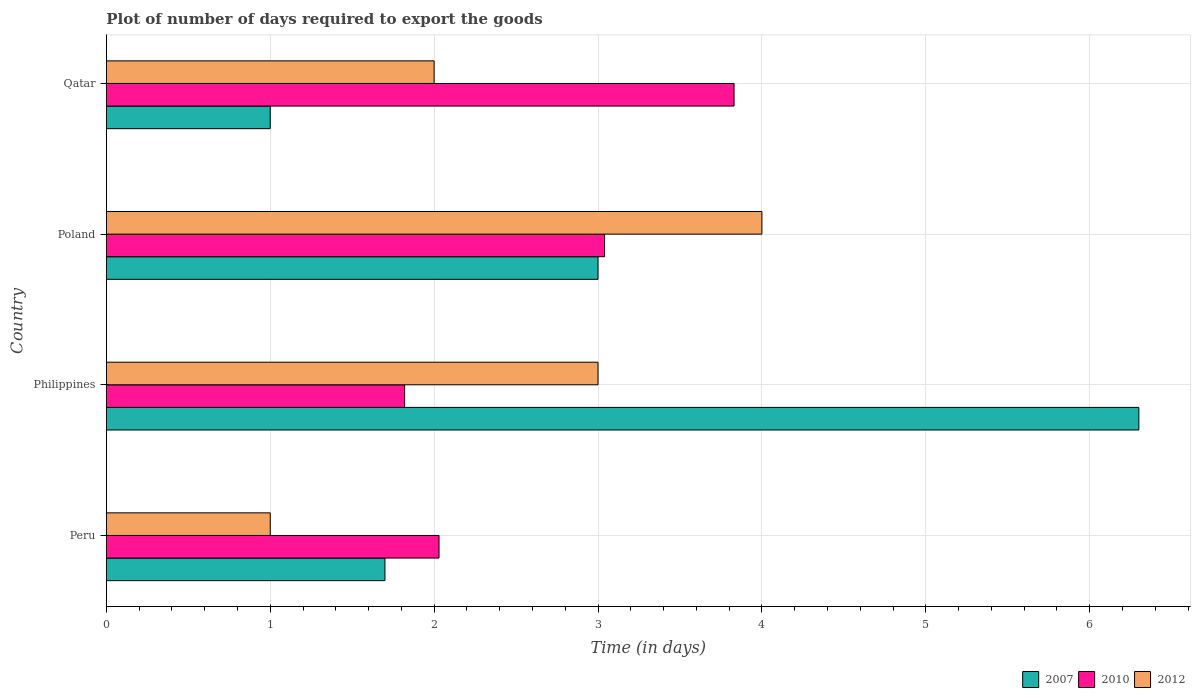How many bars are there on the 4th tick from the top?
Ensure brevity in your answer.  3. What is the label of the 1st group of bars from the top?
Offer a terse response. Qatar. What is the time required to export goods in 2010 in Philippines?
Ensure brevity in your answer.  1.82. Across all countries, what is the maximum time required to export goods in 2010?
Make the answer very short. 3.83. Across all countries, what is the minimum time required to export goods in 2010?
Offer a very short reply. 1.82. In which country was the time required to export goods in 2012 maximum?
Make the answer very short. Poland. What is the total time required to export goods in 2010 in the graph?
Ensure brevity in your answer.  10.72. What is the difference between the time required to export goods in 2010 in Poland and the time required to export goods in 2007 in Philippines?
Your response must be concise. -3.26. In how many countries, is the time required to export goods in 2007 greater than 1.6 days?
Keep it short and to the point. 3. Is the time required to export goods in 2012 in Philippines less than that in Qatar?
Ensure brevity in your answer.  No. Is the difference between the time required to export goods in 2012 in Poland and Qatar greater than the difference between the time required to export goods in 2007 in Poland and Qatar?
Ensure brevity in your answer.  No. In how many countries, is the time required to export goods in 2012 greater than the average time required to export goods in 2012 taken over all countries?
Ensure brevity in your answer.  2. What does the 3rd bar from the bottom in Poland represents?
Keep it short and to the point. 2012. How many bars are there?
Offer a terse response. 12. Does the graph contain grids?
Ensure brevity in your answer.  Yes. Where does the legend appear in the graph?
Your response must be concise. Bottom right. How many legend labels are there?
Provide a short and direct response. 3. What is the title of the graph?
Offer a terse response. Plot of number of days required to export the goods. What is the label or title of the X-axis?
Your answer should be compact. Time (in days). What is the Time (in days) in 2010 in Peru?
Make the answer very short. 2.03. What is the Time (in days) of 2012 in Peru?
Keep it short and to the point. 1. What is the Time (in days) of 2010 in Philippines?
Offer a very short reply. 1.82. What is the Time (in days) of 2012 in Philippines?
Your answer should be compact. 3. What is the Time (in days) in 2010 in Poland?
Give a very brief answer. 3.04. What is the Time (in days) in 2012 in Poland?
Offer a terse response. 4. What is the Time (in days) of 2010 in Qatar?
Offer a terse response. 3.83. What is the Time (in days) in 2012 in Qatar?
Keep it short and to the point. 2. Across all countries, what is the maximum Time (in days) in 2010?
Give a very brief answer. 3.83. Across all countries, what is the minimum Time (in days) of 2007?
Offer a very short reply. 1. Across all countries, what is the minimum Time (in days) in 2010?
Ensure brevity in your answer.  1.82. Across all countries, what is the minimum Time (in days) of 2012?
Your response must be concise. 1. What is the total Time (in days) in 2007 in the graph?
Give a very brief answer. 12. What is the total Time (in days) of 2010 in the graph?
Give a very brief answer. 10.72. What is the difference between the Time (in days) of 2007 in Peru and that in Philippines?
Keep it short and to the point. -4.6. What is the difference between the Time (in days) in 2010 in Peru and that in Philippines?
Provide a succinct answer. 0.21. What is the difference between the Time (in days) of 2007 in Peru and that in Poland?
Ensure brevity in your answer.  -1.3. What is the difference between the Time (in days) of 2010 in Peru and that in Poland?
Your answer should be very brief. -1.01. What is the difference between the Time (in days) in 2012 in Peru and that in Poland?
Ensure brevity in your answer.  -3. What is the difference between the Time (in days) of 2010 in Philippines and that in Poland?
Offer a very short reply. -1.22. What is the difference between the Time (in days) in 2012 in Philippines and that in Poland?
Keep it short and to the point. -1. What is the difference between the Time (in days) of 2007 in Philippines and that in Qatar?
Keep it short and to the point. 5.3. What is the difference between the Time (in days) in 2010 in Philippines and that in Qatar?
Your response must be concise. -2.01. What is the difference between the Time (in days) in 2012 in Philippines and that in Qatar?
Your answer should be very brief. 1. What is the difference between the Time (in days) in 2010 in Poland and that in Qatar?
Give a very brief answer. -0.79. What is the difference between the Time (in days) of 2007 in Peru and the Time (in days) of 2010 in Philippines?
Give a very brief answer. -0.12. What is the difference between the Time (in days) of 2007 in Peru and the Time (in days) of 2012 in Philippines?
Give a very brief answer. -1.3. What is the difference between the Time (in days) of 2010 in Peru and the Time (in days) of 2012 in Philippines?
Offer a terse response. -0.97. What is the difference between the Time (in days) in 2007 in Peru and the Time (in days) in 2010 in Poland?
Your response must be concise. -1.34. What is the difference between the Time (in days) in 2010 in Peru and the Time (in days) in 2012 in Poland?
Offer a very short reply. -1.97. What is the difference between the Time (in days) in 2007 in Peru and the Time (in days) in 2010 in Qatar?
Offer a very short reply. -2.13. What is the difference between the Time (in days) in 2007 in Peru and the Time (in days) in 2012 in Qatar?
Give a very brief answer. -0.3. What is the difference between the Time (in days) in 2007 in Philippines and the Time (in days) in 2010 in Poland?
Ensure brevity in your answer.  3.26. What is the difference between the Time (in days) in 2007 in Philippines and the Time (in days) in 2012 in Poland?
Provide a short and direct response. 2.3. What is the difference between the Time (in days) of 2010 in Philippines and the Time (in days) of 2012 in Poland?
Your answer should be compact. -2.18. What is the difference between the Time (in days) of 2007 in Philippines and the Time (in days) of 2010 in Qatar?
Make the answer very short. 2.47. What is the difference between the Time (in days) of 2010 in Philippines and the Time (in days) of 2012 in Qatar?
Offer a terse response. -0.18. What is the difference between the Time (in days) of 2007 in Poland and the Time (in days) of 2010 in Qatar?
Give a very brief answer. -0.83. What is the average Time (in days) of 2010 per country?
Ensure brevity in your answer.  2.68. What is the difference between the Time (in days) of 2007 and Time (in days) of 2010 in Peru?
Offer a terse response. -0.33. What is the difference between the Time (in days) in 2007 and Time (in days) in 2012 in Peru?
Offer a terse response. 0.7. What is the difference between the Time (in days) of 2010 and Time (in days) of 2012 in Peru?
Offer a very short reply. 1.03. What is the difference between the Time (in days) of 2007 and Time (in days) of 2010 in Philippines?
Keep it short and to the point. 4.48. What is the difference between the Time (in days) in 2010 and Time (in days) in 2012 in Philippines?
Offer a terse response. -1.18. What is the difference between the Time (in days) of 2007 and Time (in days) of 2010 in Poland?
Your answer should be very brief. -0.04. What is the difference between the Time (in days) of 2007 and Time (in days) of 2012 in Poland?
Ensure brevity in your answer.  -1. What is the difference between the Time (in days) in 2010 and Time (in days) in 2012 in Poland?
Your answer should be compact. -0.96. What is the difference between the Time (in days) of 2007 and Time (in days) of 2010 in Qatar?
Give a very brief answer. -2.83. What is the difference between the Time (in days) in 2007 and Time (in days) in 2012 in Qatar?
Offer a very short reply. -1. What is the difference between the Time (in days) of 2010 and Time (in days) of 2012 in Qatar?
Provide a short and direct response. 1.83. What is the ratio of the Time (in days) of 2007 in Peru to that in Philippines?
Provide a succinct answer. 0.27. What is the ratio of the Time (in days) in 2010 in Peru to that in Philippines?
Your answer should be compact. 1.12. What is the ratio of the Time (in days) of 2012 in Peru to that in Philippines?
Your answer should be compact. 0.33. What is the ratio of the Time (in days) in 2007 in Peru to that in Poland?
Your response must be concise. 0.57. What is the ratio of the Time (in days) in 2010 in Peru to that in Poland?
Provide a succinct answer. 0.67. What is the ratio of the Time (in days) of 2010 in Peru to that in Qatar?
Offer a terse response. 0.53. What is the ratio of the Time (in days) of 2012 in Peru to that in Qatar?
Provide a short and direct response. 0.5. What is the ratio of the Time (in days) in 2010 in Philippines to that in Poland?
Your response must be concise. 0.6. What is the ratio of the Time (in days) in 2010 in Philippines to that in Qatar?
Provide a short and direct response. 0.48. What is the ratio of the Time (in days) of 2012 in Philippines to that in Qatar?
Ensure brevity in your answer.  1.5. What is the ratio of the Time (in days) of 2007 in Poland to that in Qatar?
Provide a succinct answer. 3. What is the ratio of the Time (in days) of 2010 in Poland to that in Qatar?
Make the answer very short. 0.79. What is the difference between the highest and the second highest Time (in days) in 2007?
Offer a terse response. 3.3. What is the difference between the highest and the second highest Time (in days) in 2010?
Provide a short and direct response. 0.79. What is the difference between the highest and the lowest Time (in days) in 2010?
Your answer should be very brief. 2.01. 